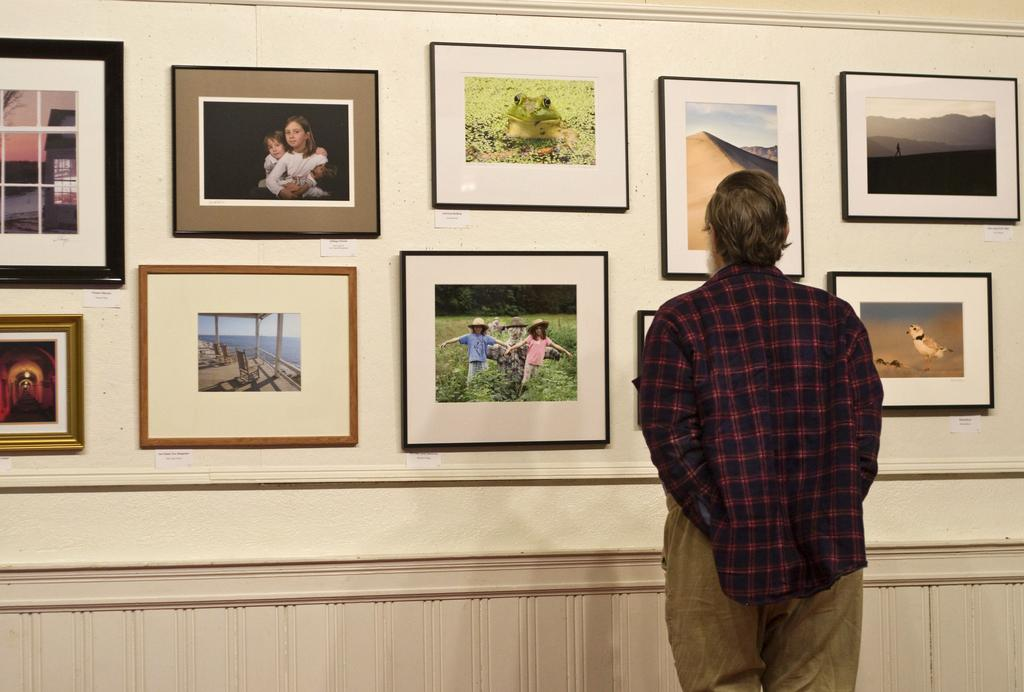What is present on the wall in the image? There are photo frames on the wall in the image. Who is present in the image? There is a man in the image. What is the man wearing? The man is wearing a red shirt. How many flies can be seen on the man's red shirt in the image? There are no flies present on the man's red shirt in the image. What route does the man take to reach the wall in the image? The image does not provide information about the man's route to reach the wall. 